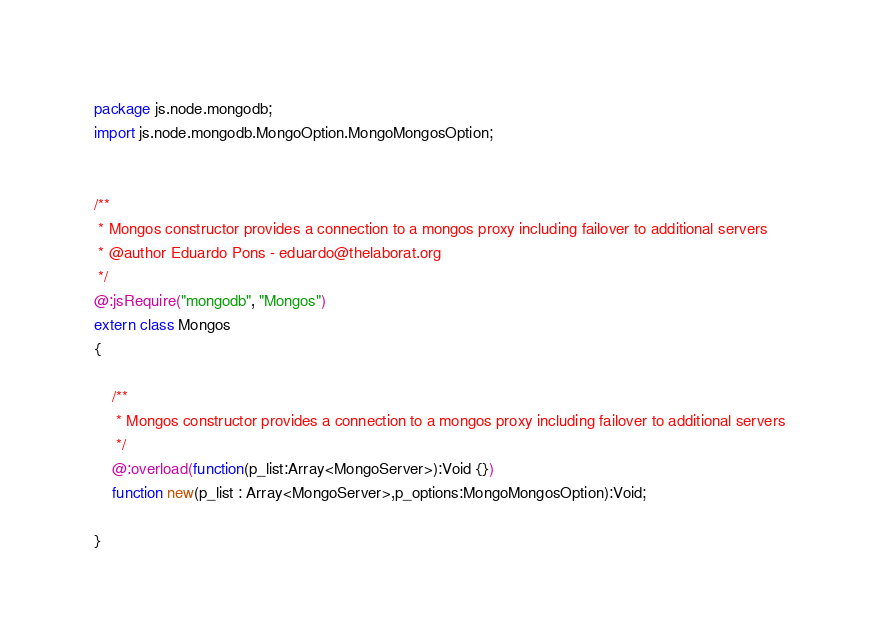<code> <loc_0><loc_0><loc_500><loc_500><_Haxe_>package js.node.mongodb;
import js.node.mongodb.MongoOption.MongoMongosOption;


/**
 * Mongos constructor provides a connection to a mongos proxy including failover to additional servers
 * @author Eduardo Pons - eduardo@thelaborat.org
 */
@:jsRequire("mongodb", "Mongos")
extern class Mongos
{

	/**
	 * Mongos constructor provides a connection to a mongos proxy including failover to additional servers
	 */
	@:overload(function(p_list:Array<MongoServer>):Void {})
	function new(p_list : Array<MongoServer>,p_options:MongoMongosOption):Void;
	
}</code> 